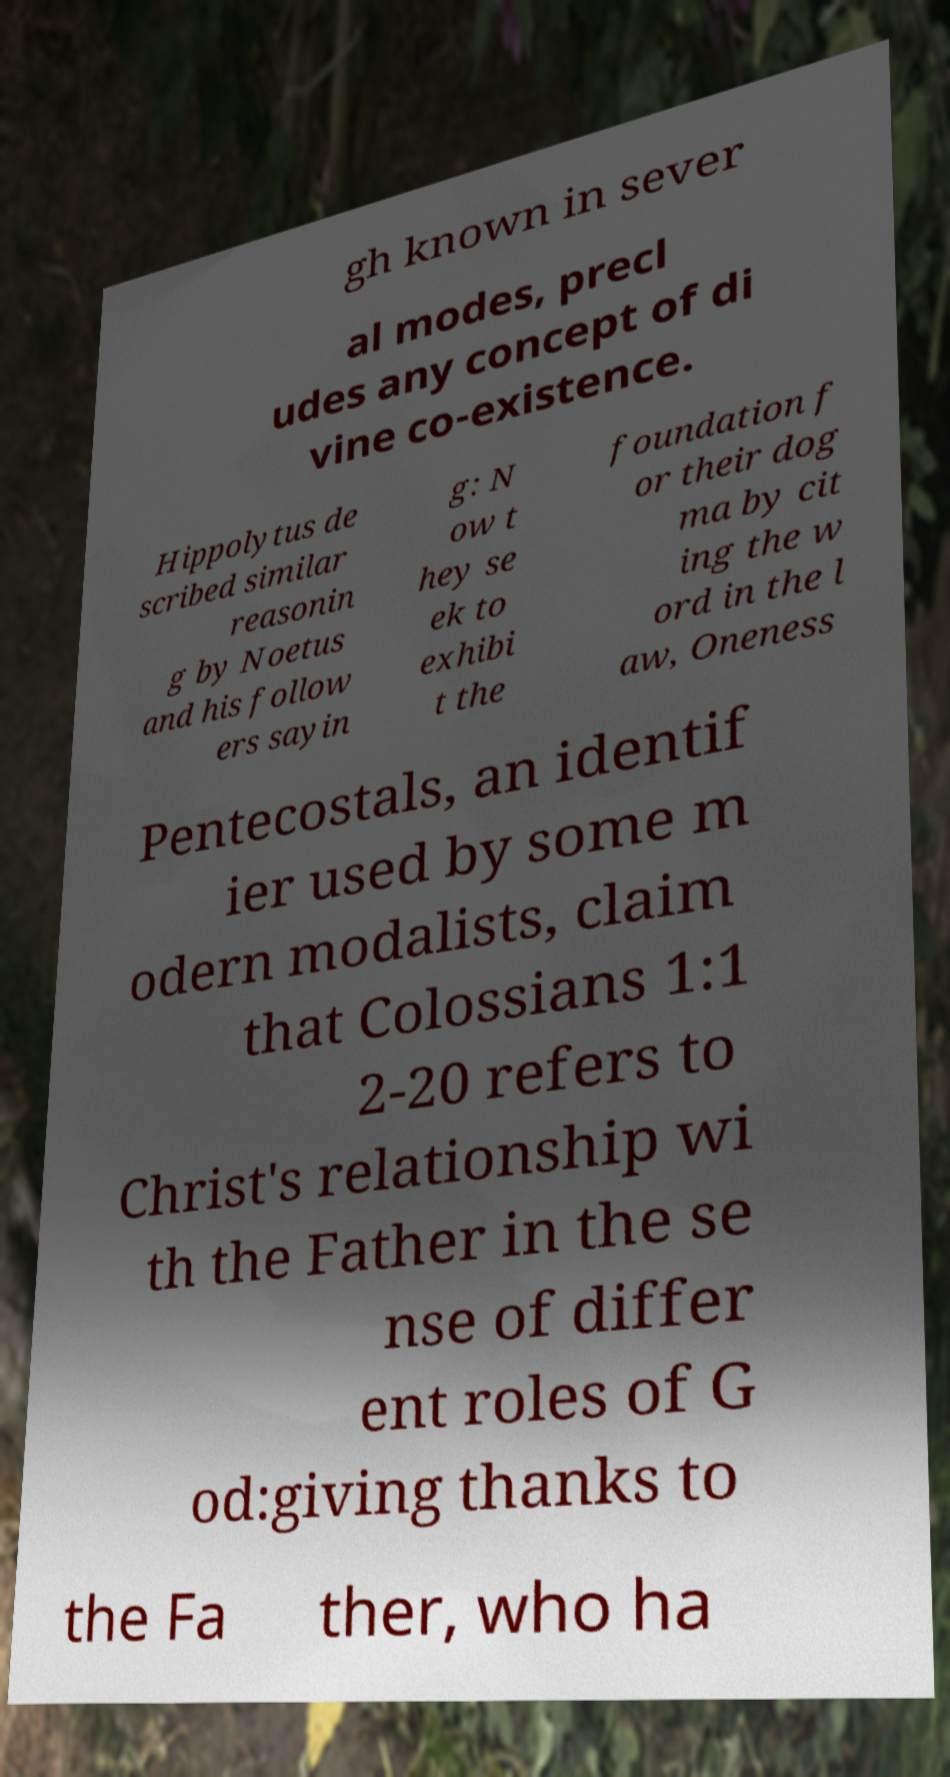I need the written content from this picture converted into text. Can you do that? gh known in sever al modes, precl udes any concept of di vine co-existence. Hippolytus de scribed similar reasonin g by Noetus and his follow ers sayin g: N ow t hey se ek to exhibi t the foundation f or their dog ma by cit ing the w ord in the l aw, Oneness Pentecostals, an identif ier used by some m odern modalists, claim that Colossians 1:1 2-20 refers to Christ's relationship wi th the Father in the se nse of differ ent roles of G od:giving thanks to the Fa ther, who ha 